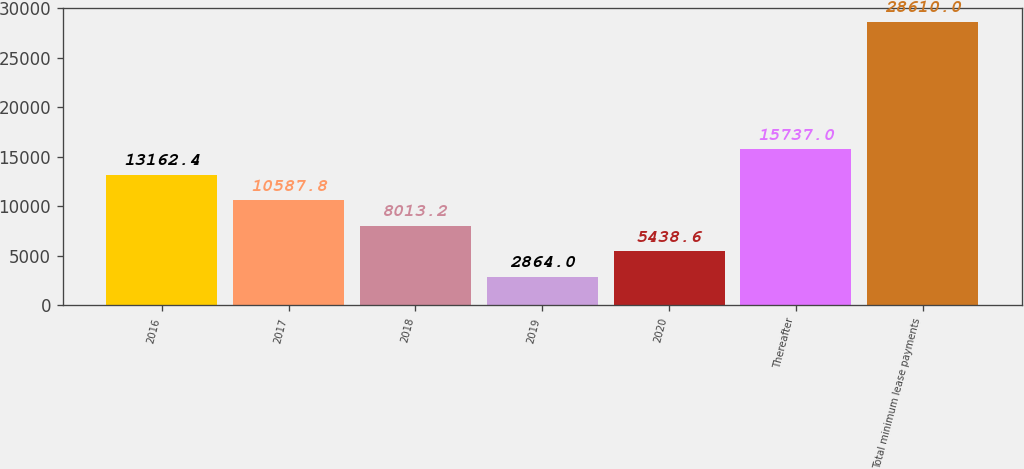<chart> <loc_0><loc_0><loc_500><loc_500><bar_chart><fcel>2016<fcel>2017<fcel>2018<fcel>2019<fcel>2020<fcel>Thereafter<fcel>Total minimum lease payments<nl><fcel>13162.4<fcel>10587.8<fcel>8013.2<fcel>2864<fcel>5438.6<fcel>15737<fcel>28610<nl></chart> 